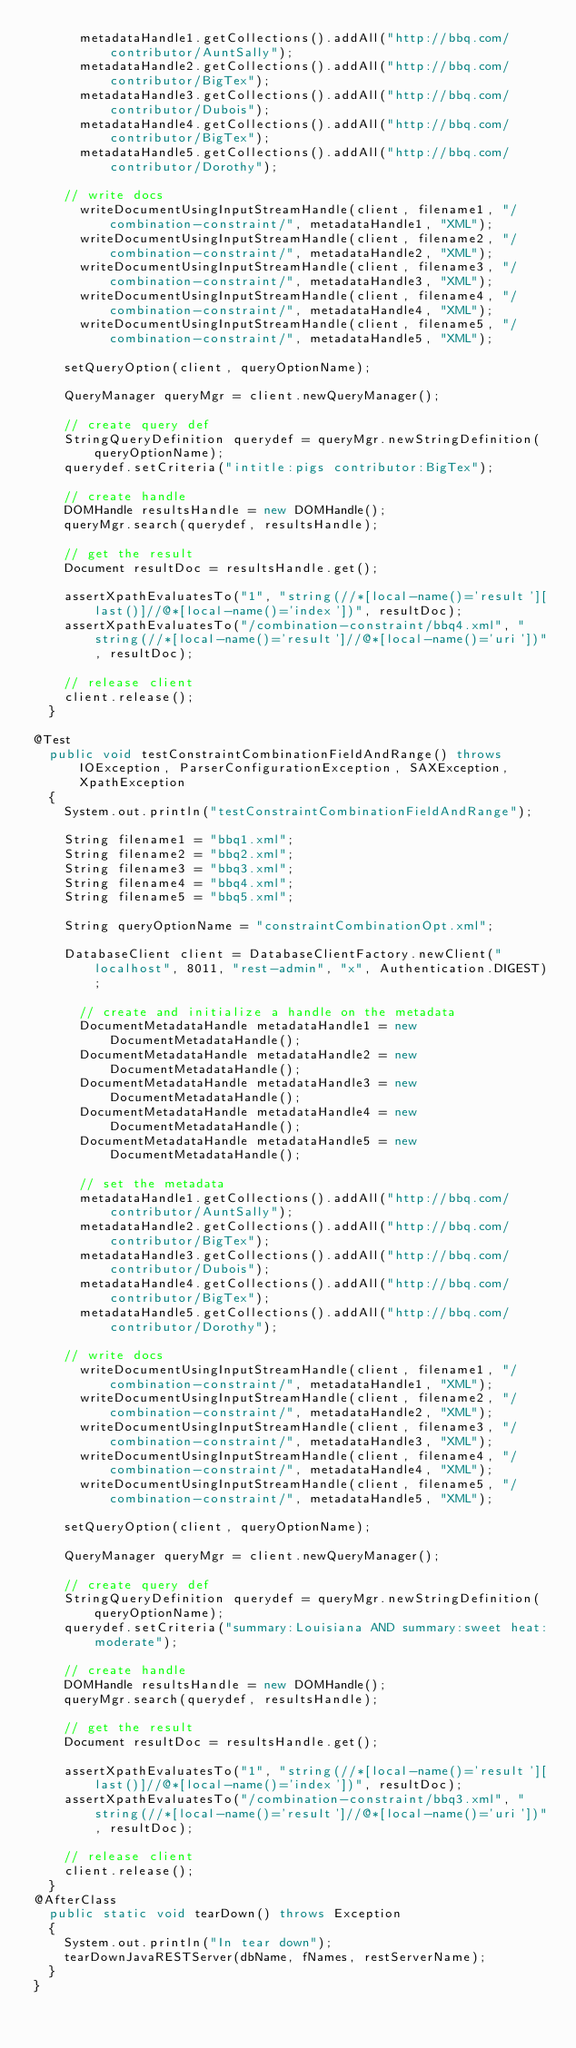Convert code to text. <code><loc_0><loc_0><loc_500><loc_500><_Java_>	    metadataHandle1.getCollections().addAll("http://bbq.com/contributor/AuntSally");
	    metadataHandle2.getCollections().addAll("http://bbq.com/contributor/BigTex");
	    metadataHandle3.getCollections().addAll("http://bbq.com/contributor/Dubois");
	    metadataHandle4.getCollections().addAll("http://bbq.com/contributor/BigTex");
	    metadataHandle5.getCollections().addAll("http://bbq.com/contributor/Dorothy");
	    
		// write docs
	    writeDocumentUsingInputStreamHandle(client, filename1, "/combination-constraint/", metadataHandle1, "XML");
	    writeDocumentUsingInputStreamHandle(client, filename2, "/combination-constraint/", metadataHandle2, "XML");
	    writeDocumentUsingInputStreamHandle(client, filename3, "/combination-constraint/", metadataHandle3, "XML");
	    writeDocumentUsingInputStreamHandle(client, filename4, "/combination-constraint/", metadataHandle4, "XML");
	    writeDocumentUsingInputStreamHandle(client, filename5, "/combination-constraint/", metadataHandle5, "XML");
		
		setQueryOption(client, queryOptionName);
		
		QueryManager queryMgr = client.newQueryManager();
		
		// create query def
		StringQueryDefinition querydef = queryMgr.newStringDefinition(queryOptionName);
		querydef.setCriteria("intitle:pigs contributor:BigTex");
		
		// create handle
		DOMHandle resultsHandle = new DOMHandle();
		queryMgr.search(querydef, resultsHandle);
		
		// get the result
		Document resultDoc = resultsHandle.get();
		
		assertXpathEvaluatesTo("1", "string(//*[local-name()='result'][last()]//@*[local-name()='index'])", resultDoc);
		assertXpathEvaluatesTo("/combination-constraint/bbq4.xml", "string(//*[local-name()='result']//@*[local-name()='uri'])", resultDoc);
		
		// release client
		client.release();		
	}

@Test
	public void testConstraintCombinationFieldAndRange() throws IOException, ParserConfigurationException, SAXException, XpathException
	{	
		System.out.println("testConstraintCombinationFieldAndRange");
		
		String filename1 = "bbq1.xml";
		String filename2 = "bbq2.xml";
		String filename3 = "bbq3.xml";
		String filename4 = "bbq4.xml";
		String filename5 = "bbq5.xml";
		
		String queryOptionName = "constraintCombinationOpt.xml";

		DatabaseClient client = DatabaseClientFactory.newClient("localhost", 8011, "rest-admin", "x", Authentication.DIGEST);
				
	    // create and initialize a handle on the metadata
	    DocumentMetadataHandle metadataHandle1 = new DocumentMetadataHandle();
	    DocumentMetadataHandle metadataHandle2 = new DocumentMetadataHandle();
	    DocumentMetadataHandle metadataHandle3 = new DocumentMetadataHandle();
	    DocumentMetadataHandle metadataHandle4 = new DocumentMetadataHandle();
	    DocumentMetadataHandle metadataHandle5 = new DocumentMetadataHandle();
		
	    // set the metadata
	    metadataHandle1.getCollections().addAll("http://bbq.com/contributor/AuntSally");
	    metadataHandle2.getCollections().addAll("http://bbq.com/contributor/BigTex");
	    metadataHandle3.getCollections().addAll("http://bbq.com/contributor/Dubois");
	    metadataHandle4.getCollections().addAll("http://bbq.com/contributor/BigTex");
	    metadataHandle5.getCollections().addAll("http://bbq.com/contributor/Dorothy");
	    
		// write docs
	    writeDocumentUsingInputStreamHandle(client, filename1, "/combination-constraint/", metadataHandle1, "XML");
	    writeDocumentUsingInputStreamHandle(client, filename2, "/combination-constraint/", metadataHandle2, "XML");
	    writeDocumentUsingInputStreamHandle(client, filename3, "/combination-constraint/", metadataHandle3, "XML");
	    writeDocumentUsingInputStreamHandle(client, filename4, "/combination-constraint/", metadataHandle4, "XML");
	    writeDocumentUsingInputStreamHandle(client, filename5, "/combination-constraint/", metadataHandle5, "XML");
		
		setQueryOption(client, queryOptionName);
		
		QueryManager queryMgr = client.newQueryManager();
		
		// create query def
		StringQueryDefinition querydef = queryMgr.newStringDefinition(queryOptionName);
		querydef.setCriteria("summary:Louisiana AND summary:sweet heat:moderate");
		
		// create handle
		DOMHandle resultsHandle = new DOMHandle();
		queryMgr.search(querydef, resultsHandle);
		
		// get the result
		Document resultDoc = resultsHandle.get();
		
		assertXpathEvaluatesTo("1", "string(//*[local-name()='result'][last()]//@*[local-name()='index'])", resultDoc);
		assertXpathEvaluatesTo("/combination-constraint/bbq3.xml", "string(//*[local-name()='result']//@*[local-name()='uri'])", resultDoc);
		
		// release client
		client.release();		
	}
@AfterClass
	public static void tearDown() throws Exception
	{
		System.out.println("In tear down");
		tearDownJavaRESTServer(dbName, fNames, restServerName);
	}
}
</code> 